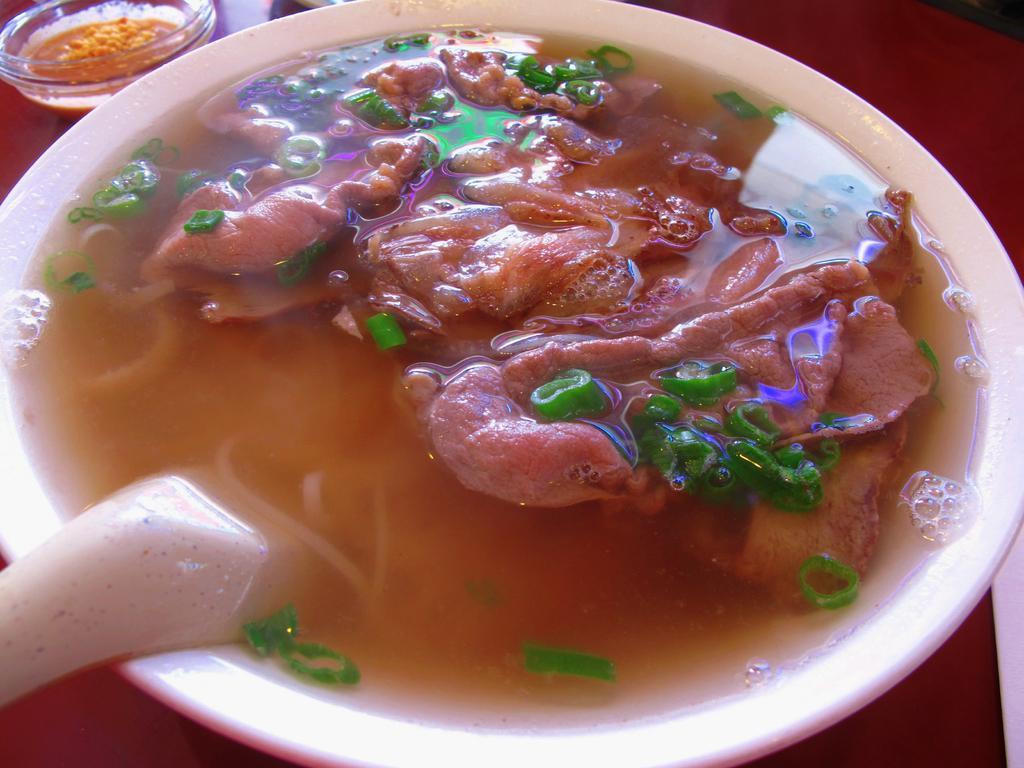Can you describe this image briefly? This image consist of food and there is a spoon in the bowl. 